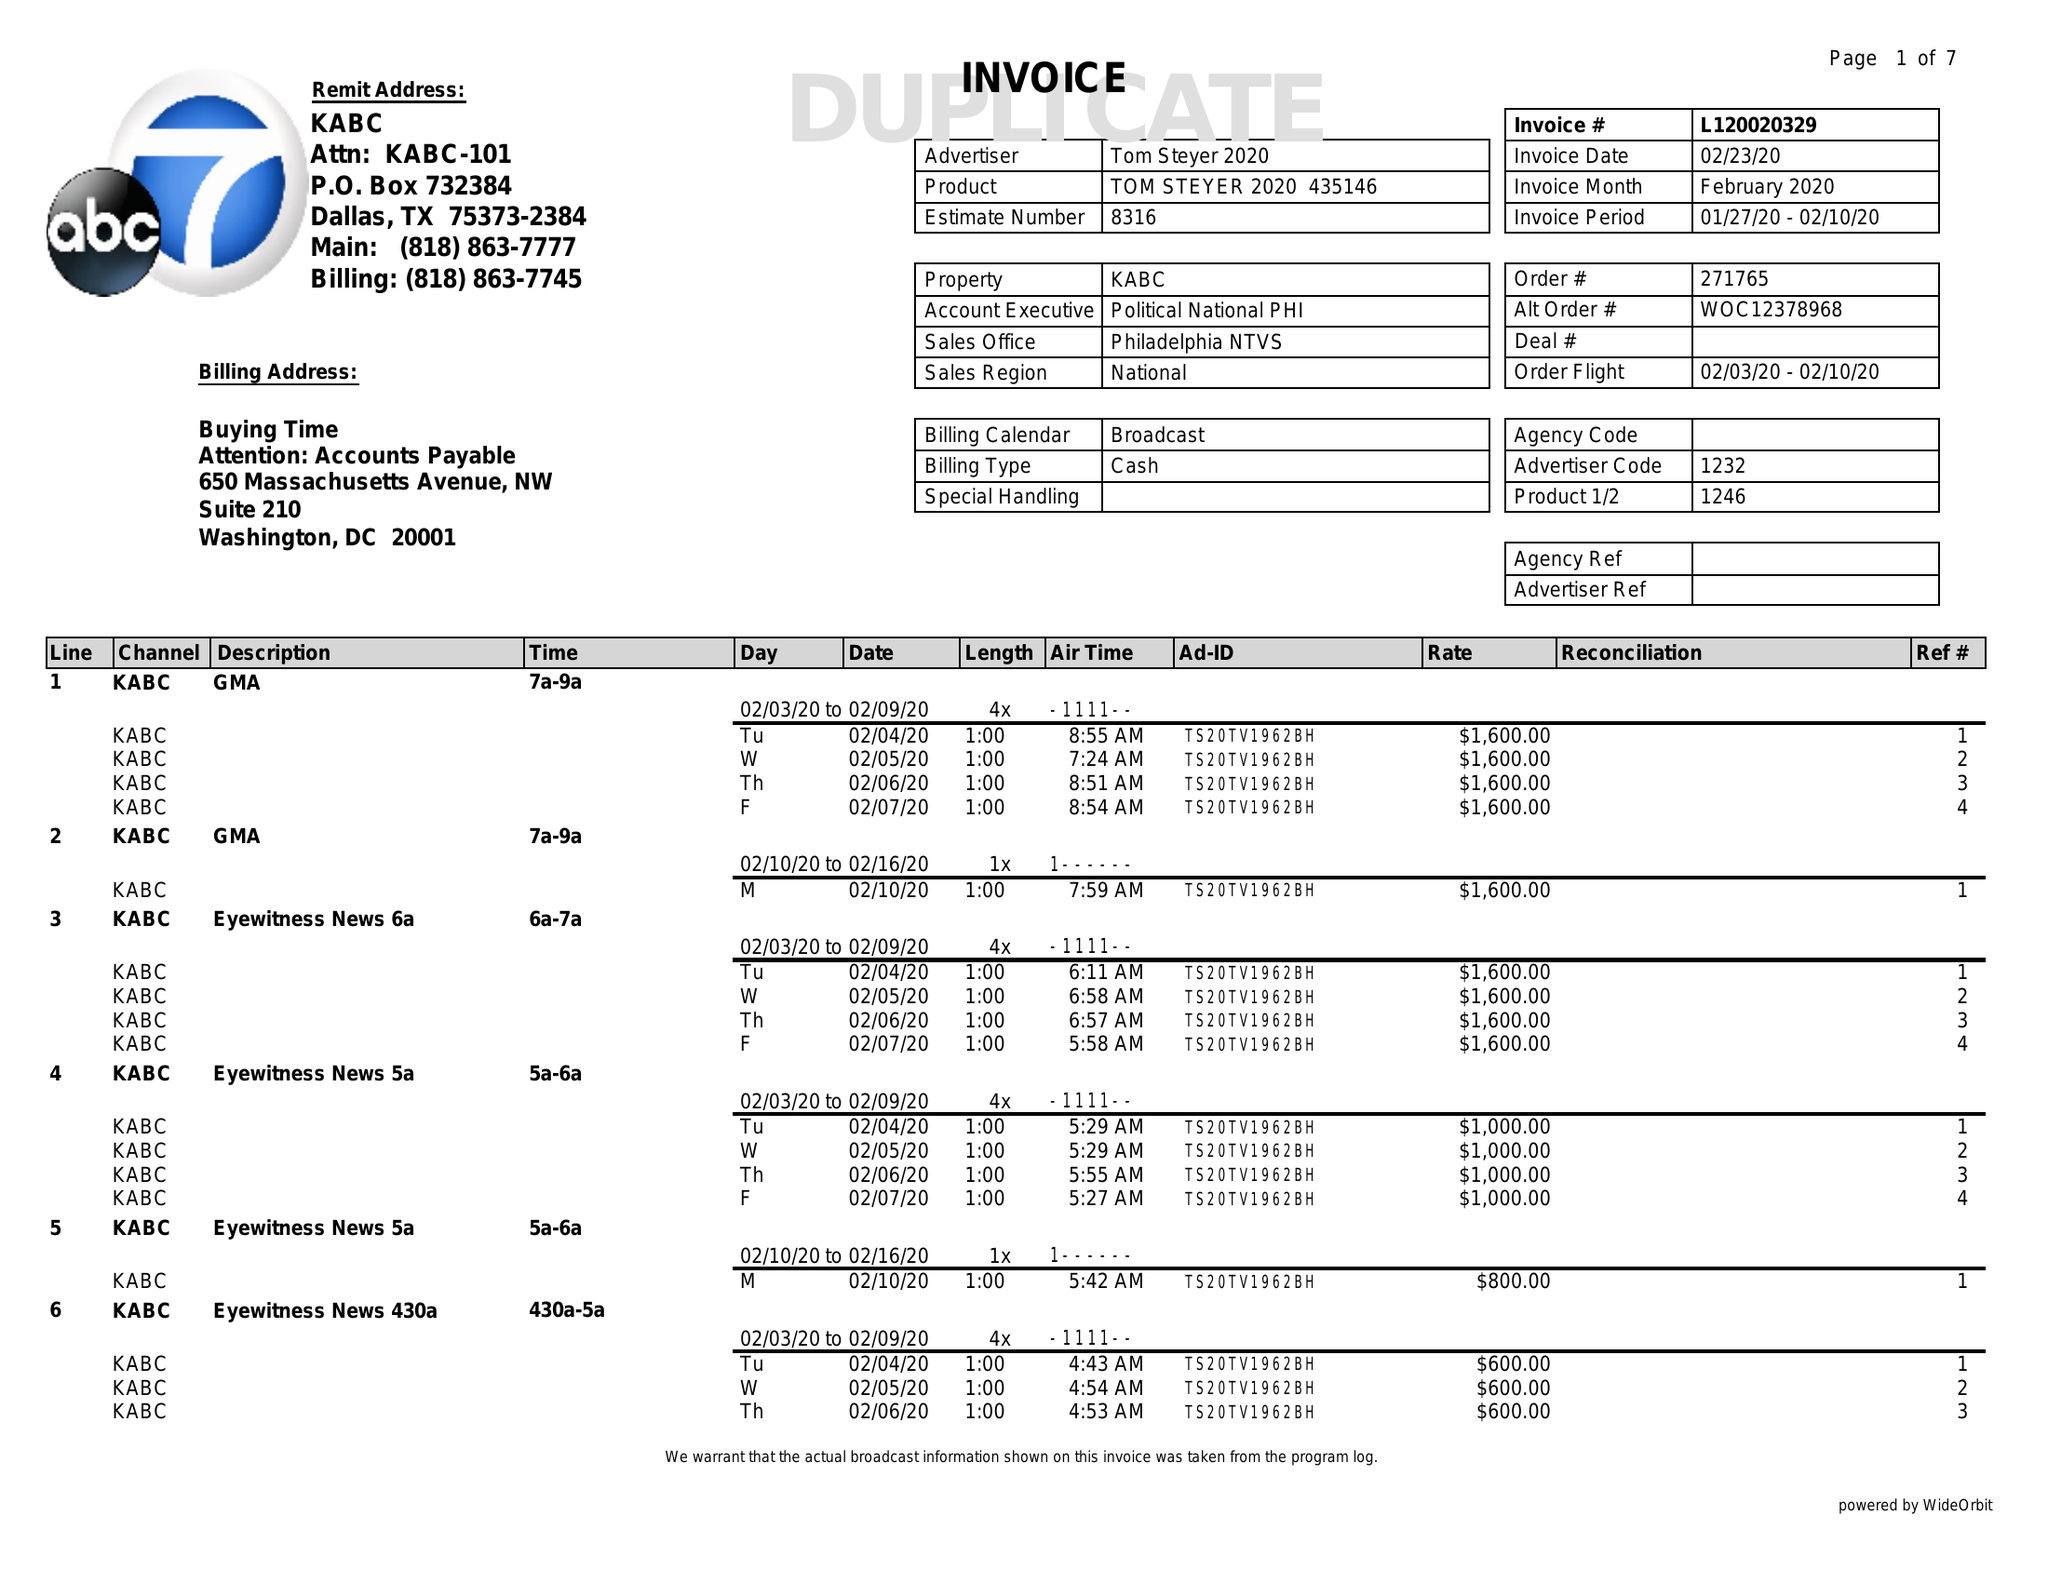What is the value for the flight_to?
Answer the question using a single word or phrase. 02/10/20 